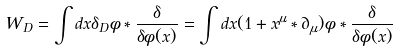<formula> <loc_0><loc_0><loc_500><loc_500>W _ { D } = \int d x \delta _ { D } \phi * \frac { \delta } { \delta \phi ( x ) } = \int d x ( 1 + x ^ { \mu } * \partial _ { \mu } ) \phi * \frac { \delta } { \delta \phi ( x ) }</formula> 